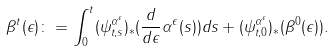<formula> <loc_0><loc_0><loc_500><loc_500>\beta ^ { t } ( \epsilon ) \colon = \int _ { 0 } ^ { t } ( \psi ^ { \alpha ^ { \epsilon } } _ { t , s } ) _ { * } ( \frac { d } { d \epsilon } \alpha ^ { \epsilon } ( s ) ) d s + ( \psi _ { t , 0 } ^ { \alpha ^ { \epsilon } } ) _ { * } ( \beta ^ { 0 } ( \epsilon ) ) .</formula> 